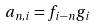<formula> <loc_0><loc_0><loc_500><loc_500>a _ { n , i } = f _ { i - n } g _ { i }</formula> 